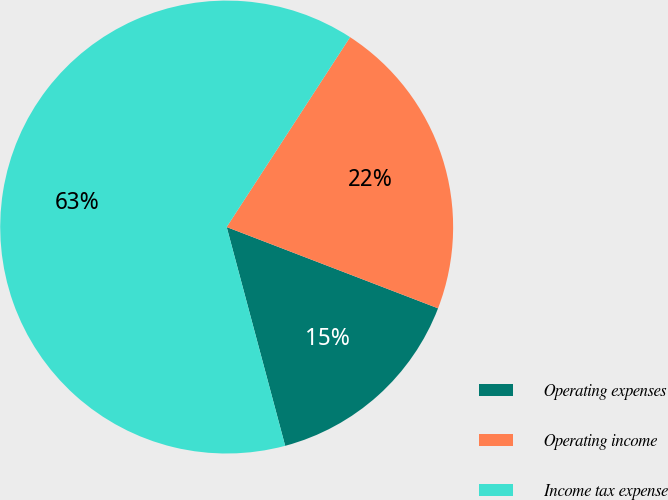<chart> <loc_0><loc_0><loc_500><loc_500><pie_chart><fcel>Operating expenses<fcel>Operating income<fcel>Income tax expense<nl><fcel>15.0%<fcel>21.67%<fcel>63.33%<nl></chart> 